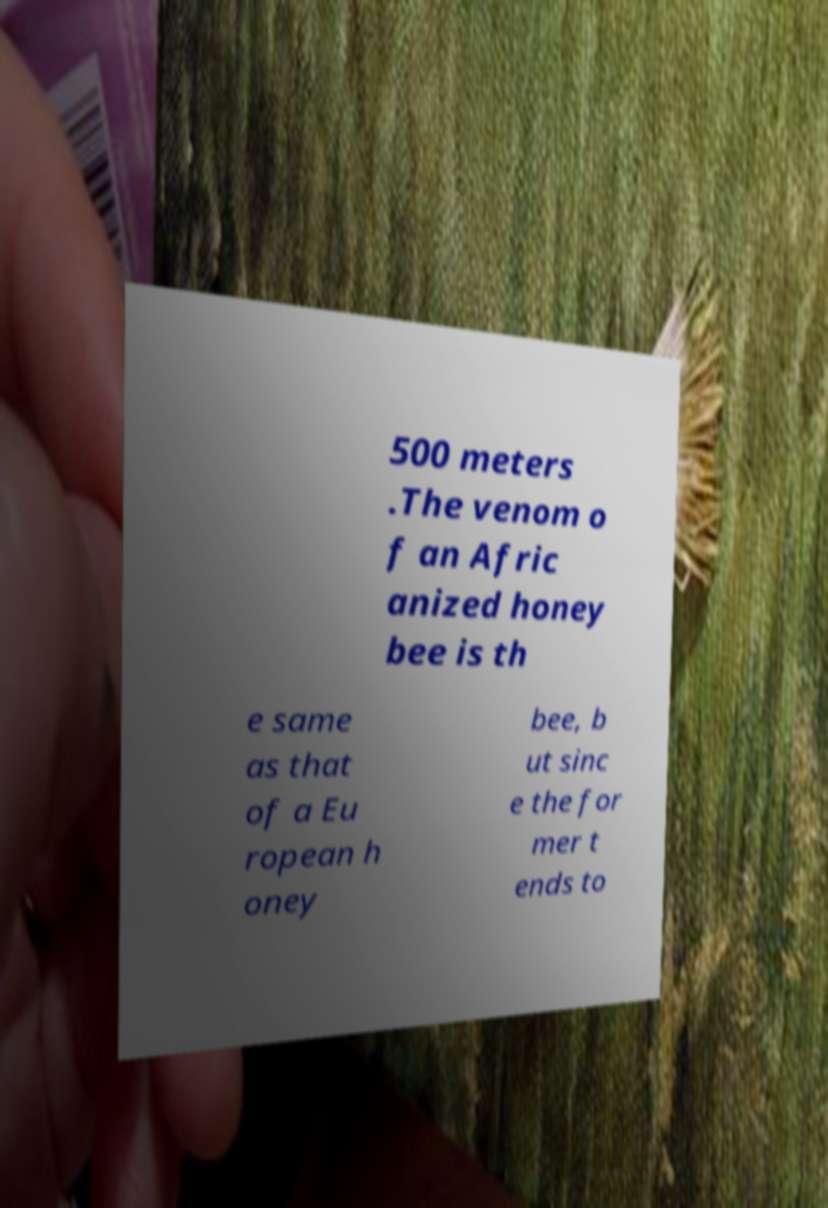What messages or text are displayed in this image? I need them in a readable, typed format. 500 meters .The venom o f an Afric anized honey bee is th e same as that of a Eu ropean h oney bee, b ut sinc e the for mer t ends to 